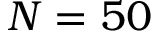Convert formula to latex. <formula><loc_0><loc_0><loc_500><loc_500>N = 5 0</formula> 